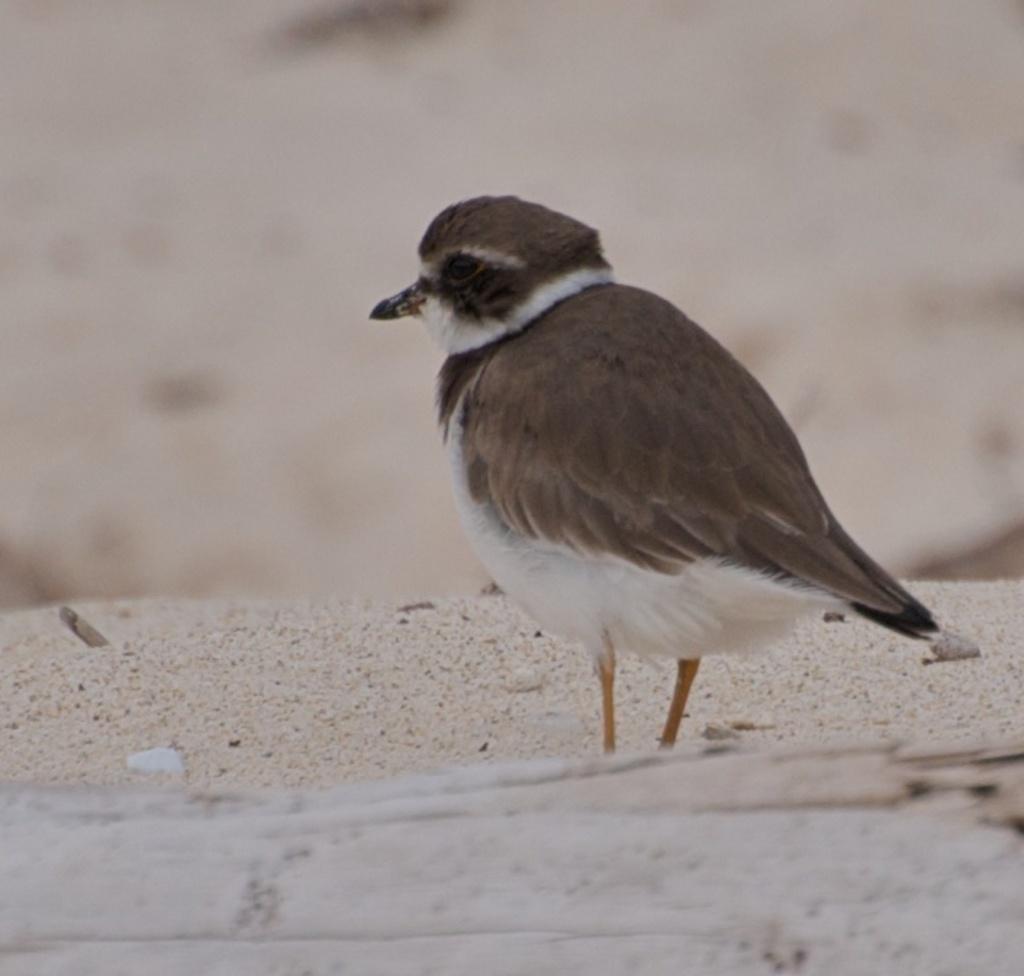Can you describe this image briefly? In this image I can see a bird which is brown, black, cream and orange in color is standing on the ground and I can see the blurry background. 